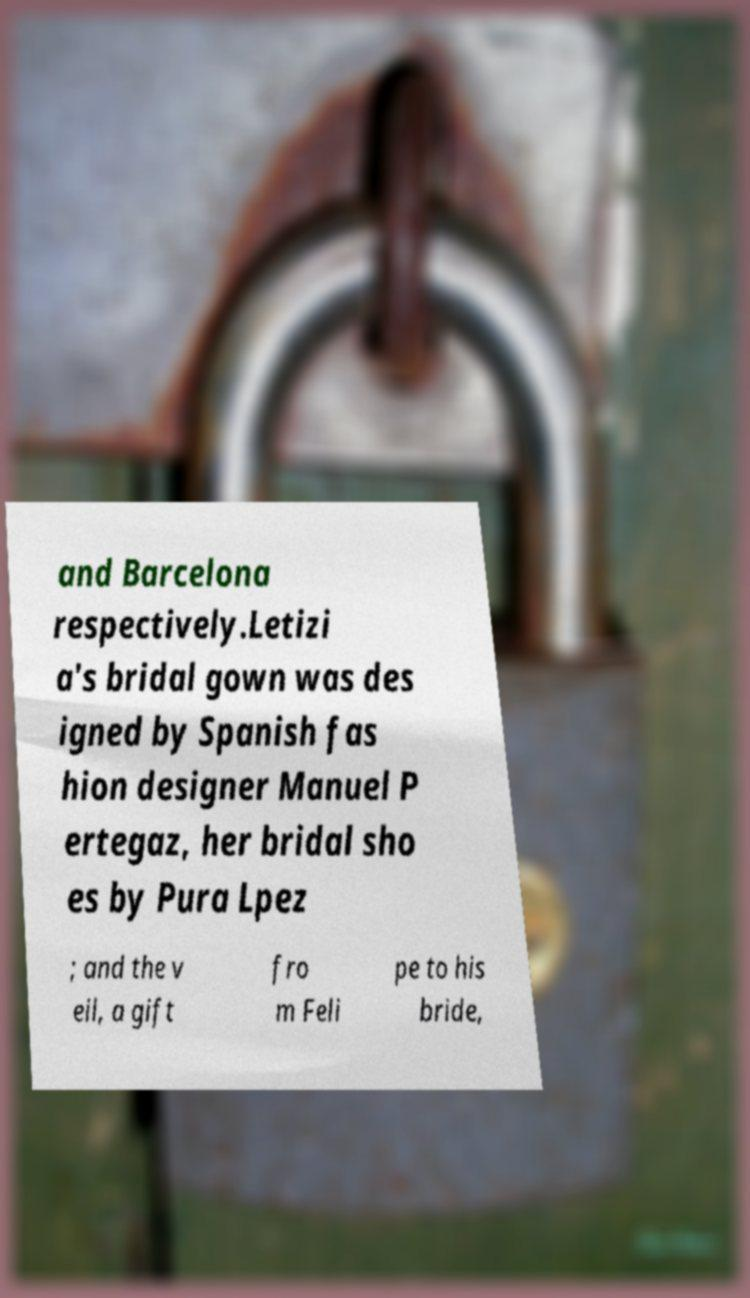Please read and relay the text visible in this image. What does it say? and Barcelona respectively.Letizi a's bridal gown was des igned by Spanish fas hion designer Manuel P ertegaz, her bridal sho es by Pura Lpez ; and the v eil, a gift fro m Feli pe to his bride, 